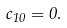Convert formula to latex. <formula><loc_0><loc_0><loc_500><loc_500>c _ { 1 0 } = 0 .</formula> 